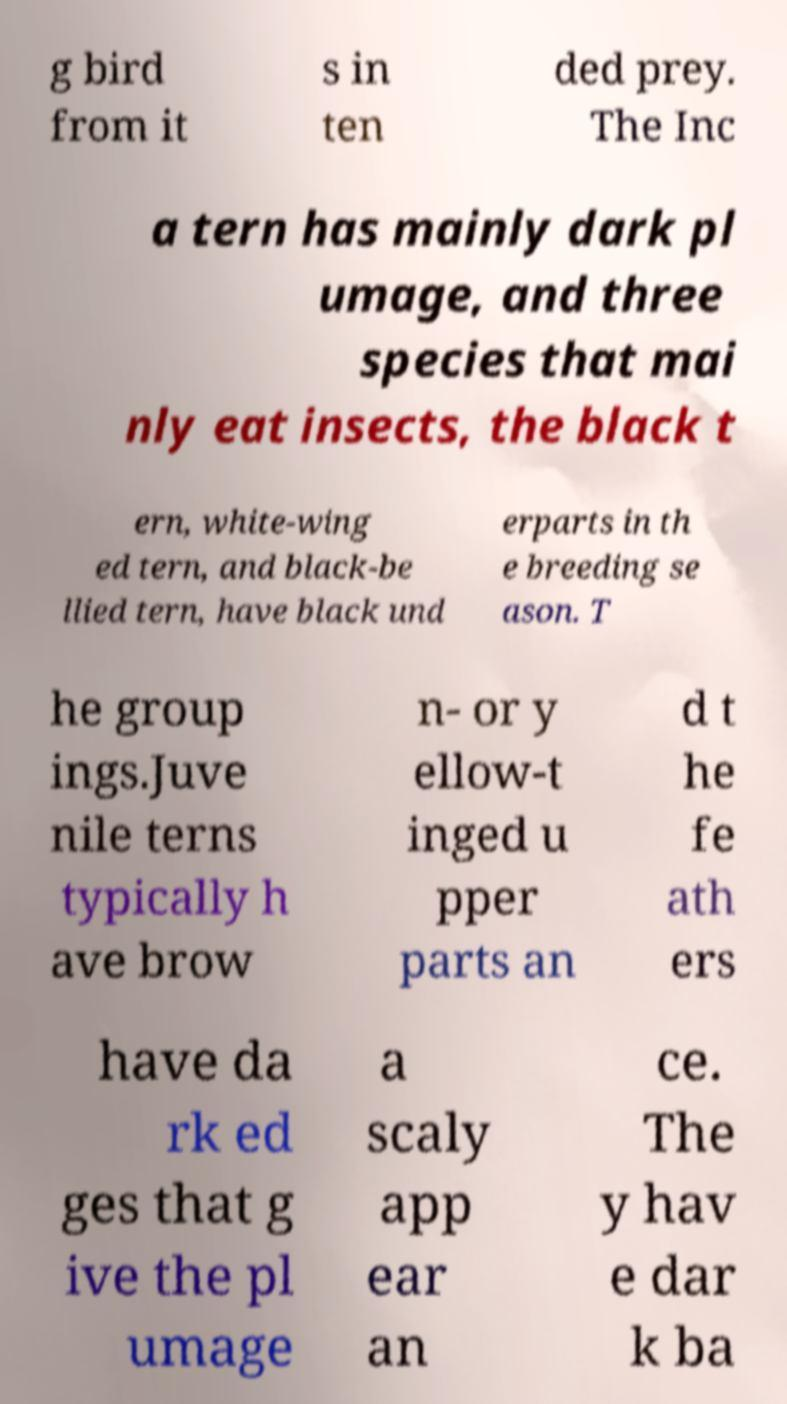Could you assist in decoding the text presented in this image and type it out clearly? g bird from it s in ten ded prey. The Inc a tern has mainly dark pl umage, and three species that mai nly eat insects, the black t ern, white-wing ed tern, and black-be llied tern, have black und erparts in th e breeding se ason. T he group ings.Juve nile terns typically h ave brow n- or y ellow-t inged u pper parts an d t he fe ath ers have da rk ed ges that g ive the pl umage a scaly app ear an ce. The y hav e dar k ba 